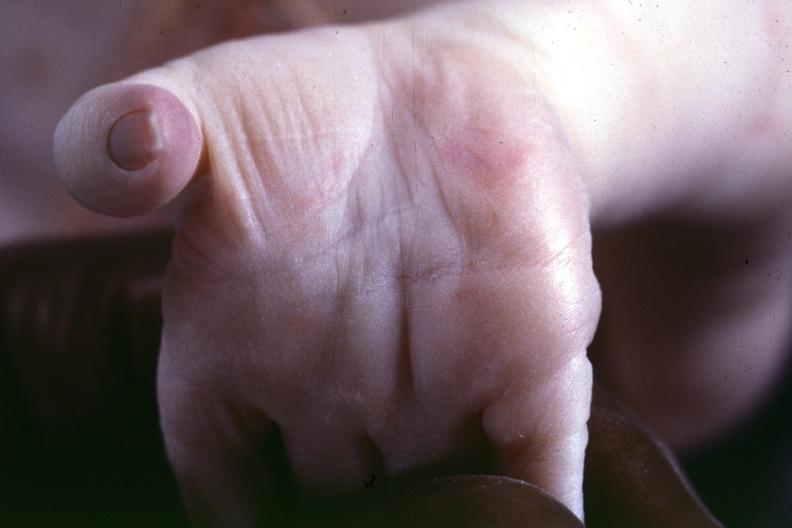what was this taken from to illustrate the difference?
Answer the question using a single word or phrase. Taken another case 